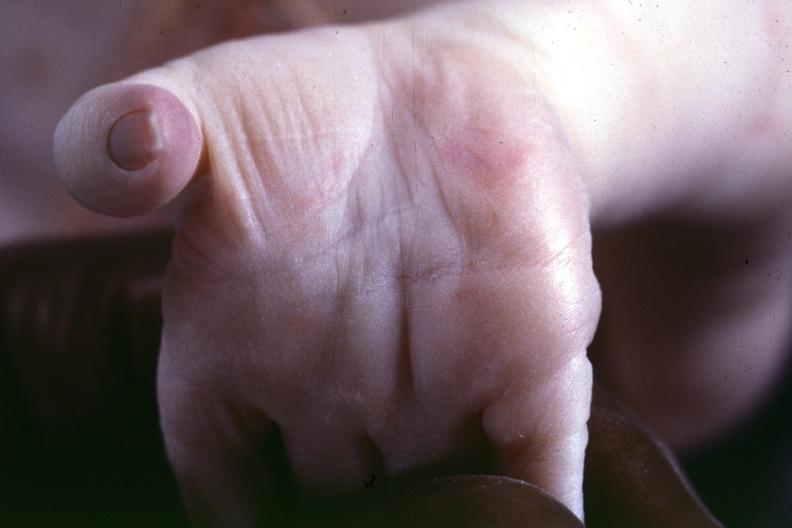what was this taken from to illustrate the difference?
Answer the question using a single word or phrase. Taken another case 